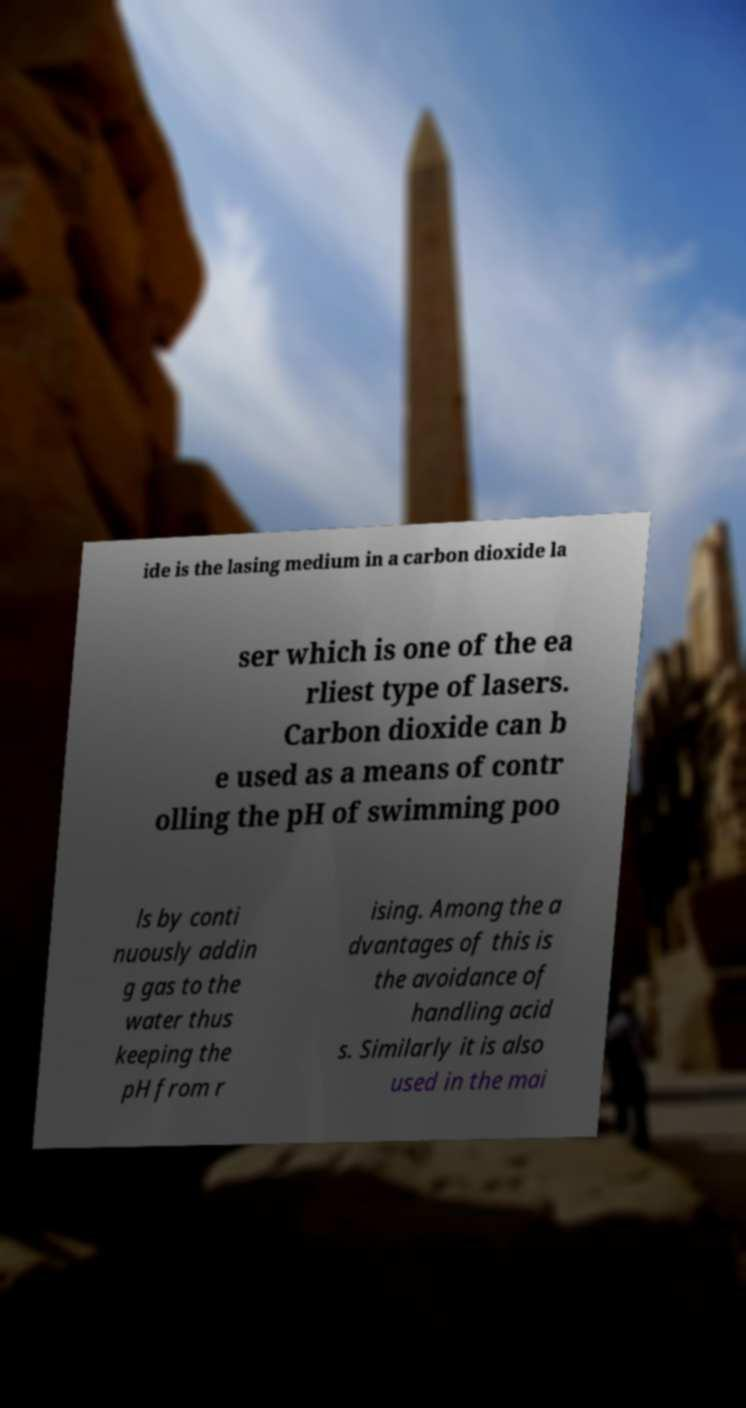Please read and relay the text visible in this image. What does it say? ide is the lasing medium in a carbon dioxide la ser which is one of the ea rliest type of lasers. Carbon dioxide can b e used as a means of contr olling the pH of swimming poo ls by conti nuously addin g gas to the water thus keeping the pH from r ising. Among the a dvantages of this is the avoidance of handling acid s. Similarly it is also used in the mai 